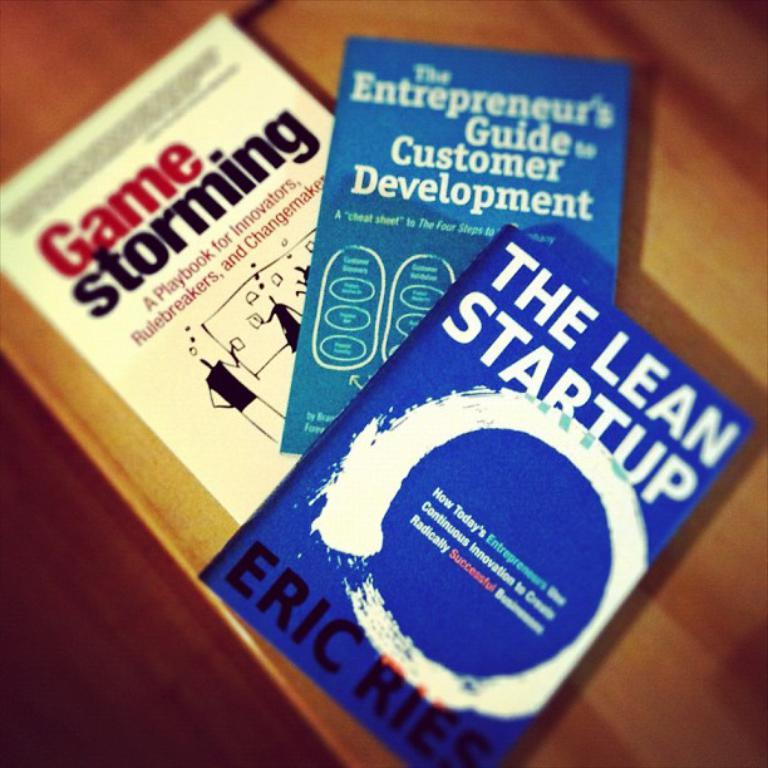<image>
Give a short and clear explanation of the subsequent image. A collection of three books with the top book named The Lean Startup. 